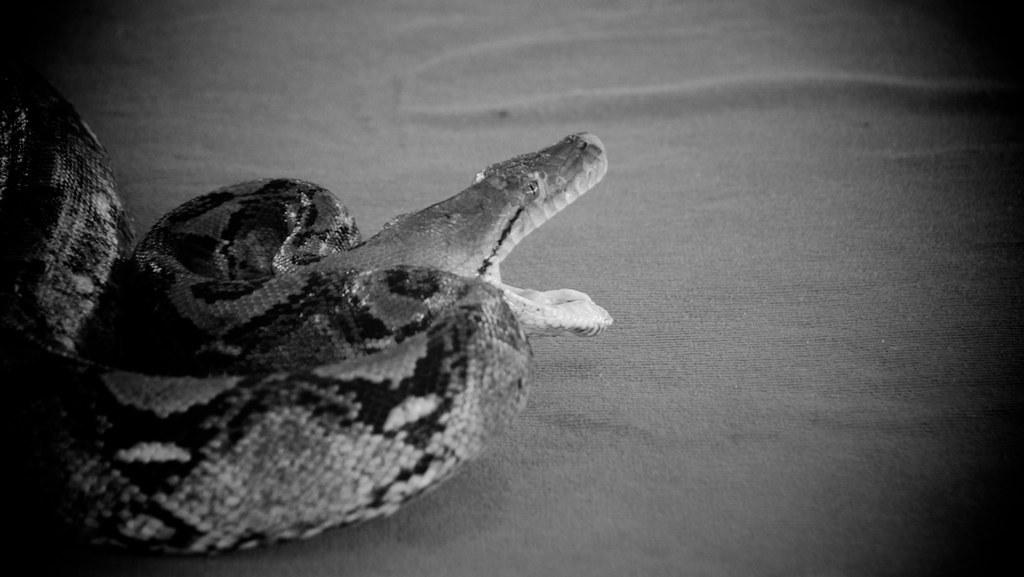What is the color scheme of the image? The image is black and white. What is the main subject of the image? There is a picture of a snake in the image. What color is the snake in the image? The snake is black in color. Where is the snake located in the image? The snake is on a surface. What type of truck can be seen in the image? There is no truck present in the image; it features a black snake on a surface. Is there a meeting taking place in the image? There is no indication of a meeting in the image, as it only shows a black snake on a surface. 